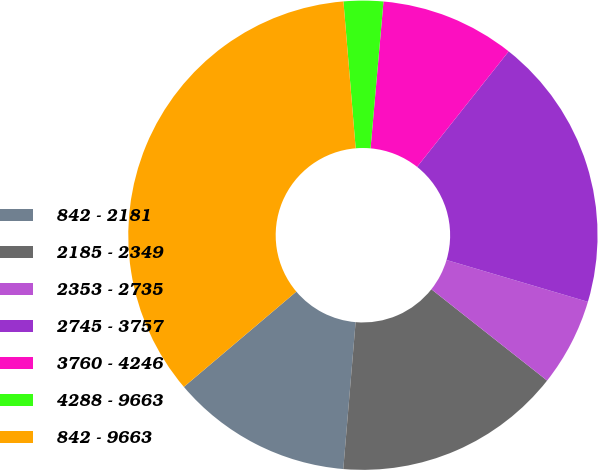<chart> <loc_0><loc_0><loc_500><loc_500><pie_chart><fcel>842 - 2181<fcel>2185 - 2349<fcel>2353 - 2735<fcel>2745 - 3757<fcel>3760 - 4246<fcel>4288 - 9663<fcel>842 - 9663<nl><fcel>12.48%<fcel>15.7%<fcel>6.05%<fcel>18.91%<fcel>9.27%<fcel>2.72%<fcel>34.86%<nl></chart> 